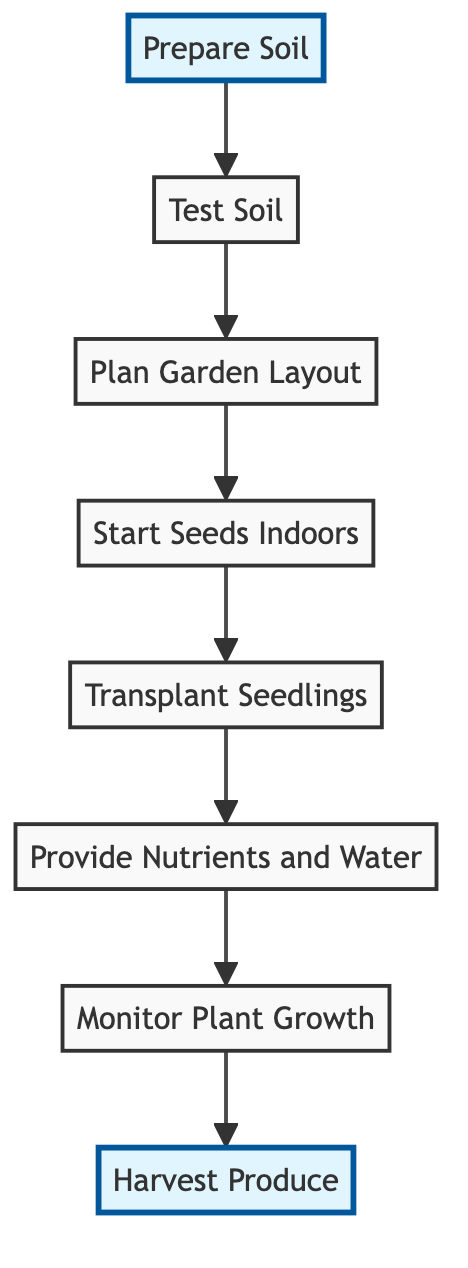What is the starting point of the flow chart? The flow chart begins with the "Prepare Soil" step, which is the initial task in the home gardening project.
Answer: Prepare Soil How many nodes are in the flow chart? There are a total of eight nodes depicting various steps in the gardening process from preparation to harvesting.
Answer: Eight What is the last step in the flow chart? The final step in the diagram is "Harvest Produce," which indicates the end goal of the gardening project.
Answer: Harvest Produce Which step comes directly after "Start Seeds Indoors"? The step that follows "Start Seeds Indoors" is "Transplant Seedlings." This order indicates the workflow of planting and later moving seedlings.
Answer: Transplant Seedlings What relationship exists between "Provide Nutrients and Water" and "Monitor Plant Growth"? "Provide Nutrients and Water" precedes "Monitor Plant Growth," indicating that plants should be nourished before monitoring their progress.
Answer: Precedes How many steps lead to the harvesting of produce? There are six steps leading up to "Harvest Produce," starting from soil preparation until the plants are actively grown.
Answer: Six What do the highlighted nodes in the flow chart represent? The highlighted nodes, "Prepare Soil" and "Harvest Produce," signify the starting and ending points of the gardening process, emphasizing their importance.
Answer: Starting and ending points Which element indicates the need for soil testing? The element "Test Soil" highlights the necessity of analyzing soil composition, which is crucial for progressing in the gardening project after soil preparation.
Answer: Test Soil What step must be completed before "Harvest Produce"? Before reaching "Harvest Produce," one must complete "Monitor Plant Growth" to ensure that plants are healthy and ready for harvesting.
Answer: Monitor Plant Growth 